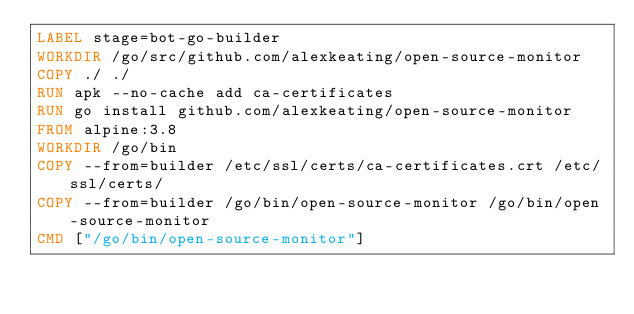Convert code to text. <code><loc_0><loc_0><loc_500><loc_500><_Dockerfile_>LABEL stage=bot-go-builder
WORKDIR /go/src/github.com/alexkeating/open-source-monitor
COPY ./ ./
RUN apk --no-cache add ca-certificates
RUN go install github.com/alexkeating/open-source-monitor
FROM alpine:3.8
WORKDIR /go/bin
COPY --from=builder /etc/ssl/certs/ca-certificates.crt /etc/ssl/certs/
COPY --from=builder /go/bin/open-source-monitor /go/bin/open-source-monitor
CMD ["/go/bin/open-source-monitor"]
</code> 